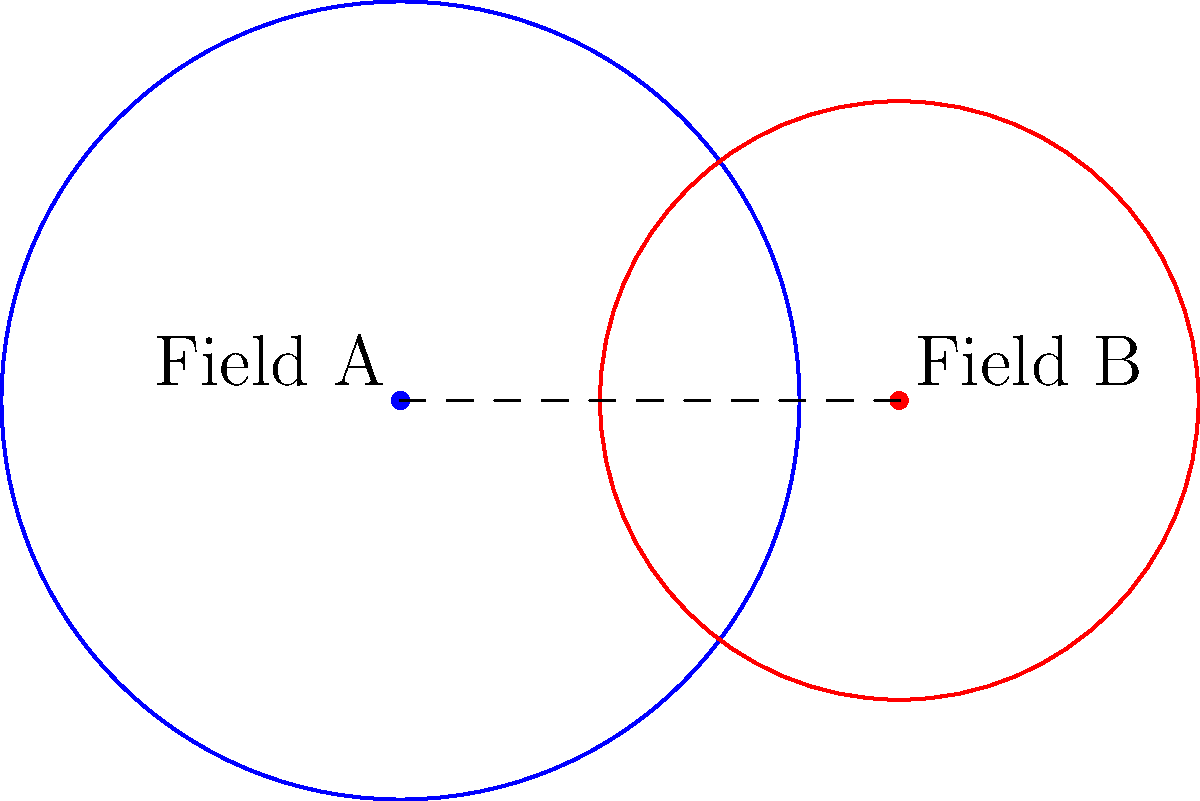As a tech-savvy equine enthusiast, you're helping a horse breeder optimize grazing areas using drone mapping technology. You've mapped two circular grazing fields: Field A with a radius of 40 meters and Field B with a radius of 30 meters. The centers of these fields are 50 meters apart. What is the area of the overlapping region between these two fields, rounded to the nearest square meter? To solve this problem, we'll use the formula for the area of intersection between two circles. Let's break it down step-by-step:

1) First, we need to calculate the distance between the centers of the circles (d):
   $d = 50$ meters (given in the question)

2) Let's define the radii:
   $r_1 = 40$ meters (Field A)
   $r_2 = 30$ meters (Field B)

3) Now, we need to calculate the angles $\theta_1$ and $\theta_2$ using the law of cosines:

   $\theta_1 = 2 \arccos(\frac{d^2 + r_1^2 - r_2^2}{2dr_1})$
   $\theta_2 = 2 \arccos(\frac{d^2 + r_2^2 - r_1^2}{2dr_2})$

4) Substitute the values:

   $\theta_1 = 2 \arccos(\frac{50^2 + 40^2 - 30^2}{2 * 50 * 40}) = 1.8735$ radians
   $\theta_2 = 2 \arccos(\frac{50^2 + 30^2 - 40^2}{2 * 50 * 30}) = 2.0944$ radians

5) The area of intersection is given by:

   $A = \frac{1}{2}r_1^2(\theta_1 - \sin\theta_1) + \frac{1}{2}r_2^2(\theta_2 - \sin\theta_2)$

6) Substitute the values:

   $A = \frac{1}{2}40^2(1.8735 - \sin(1.8735)) + \frac{1}{2}30^2(2.0944 - \sin(2.0944))$

7) Calculate:

   $A = 800(1.8735 - 0.9483) + 450(2.0944 - 0.8660)$
   $A = 800(0.9252) + 450(1.2284)$
   $A = 740.16 + 552.78$
   $A = 1292.94$ square meters

8) Rounding to the nearest square meter:

   $A \approx 1293$ square meters
Answer: 1293 square meters 